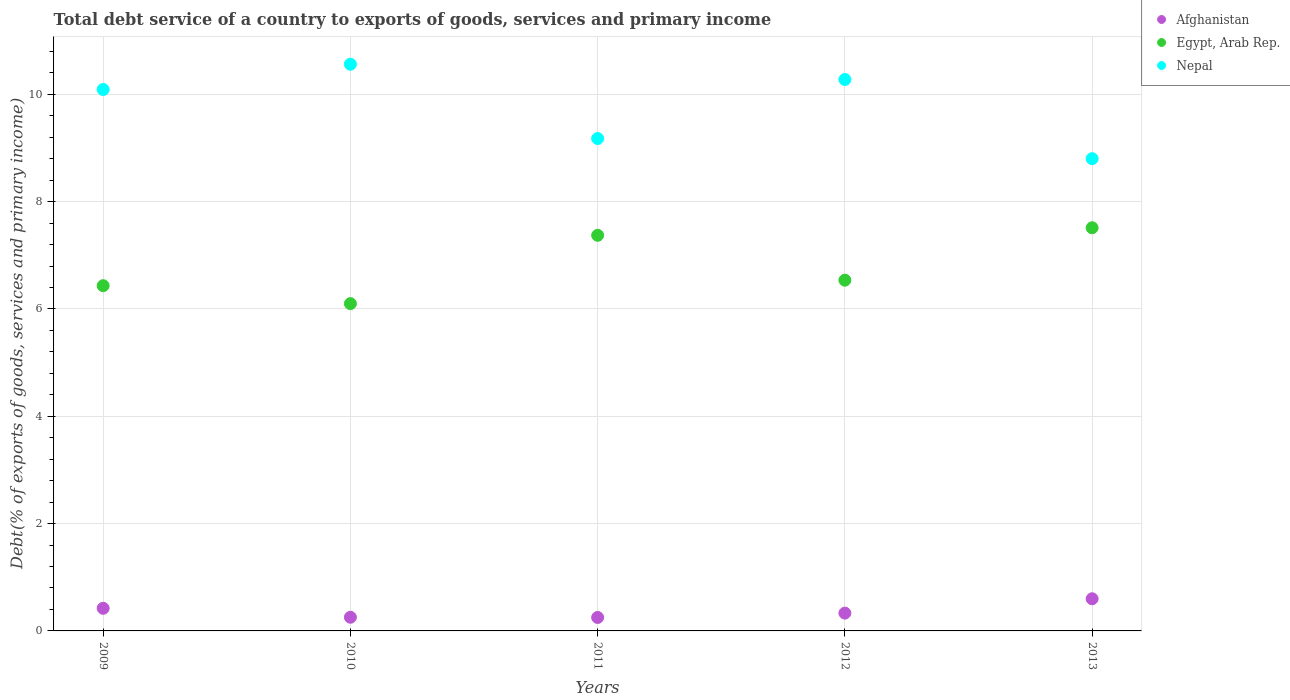How many different coloured dotlines are there?
Your response must be concise. 3. What is the total debt service in Afghanistan in 2009?
Give a very brief answer. 0.42. Across all years, what is the maximum total debt service in Afghanistan?
Your answer should be very brief. 0.6. Across all years, what is the minimum total debt service in Nepal?
Keep it short and to the point. 8.8. In which year was the total debt service in Egypt, Arab Rep. minimum?
Make the answer very short. 2010. What is the total total debt service in Afghanistan in the graph?
Offer a terse response. 1.86. What is the difference between the total debt service in Afghanistan in 2009 and that in 2011?
Offer a terse response. 0.17. What is the difference between the total debt service in Afghanistan in 2011 and the total debt service in Egypt, Arab Rep. in 2009?
Provide a succinct answer. -6.18. What is the average total debt service in Afghanistan per year?
Offer a very short reply. 0.37. In the year 2010, what is the difference between the total debt service in Egypt, Arab Rep. and total debt service in Nepal?
Your response must be concise. -4.46. What is the ratio of the total debt service in Egypt, Arab Rep. in 2009 to that in 2010?
Provide a short and direct response. 1.05. What is the difference between the highest and the second highest total debt service in Afghanistan?
Your response must be concise. 0.18. What is the difference between the highest and the lowest total debt service in Afghanistan?
Offer a terse response. 0.35. In how many years, is the total debt service in Nepal greater than the average total debt service in Nepal taken over all years?
Make the answer very short. 3. Is it the case that in every year, the sum of the total debt service in Afghanistan and total debt service in Egypt, Arab Rep.  is greater than the total debt service in Nepal?
Your answer should be compact. No. Does the total debt service in Afghanistan monotonically increase over the years?
Provide a succinct answer. No. How many dotlines are there?
Your answer should be compact. 3. Does the graph contain any zero values?
Ensure brevity in your answer.  No. Does the graph contain grids?
Ensure brevity in your answer.  Yes. Where does the legend appear in the graph?
Your response must be concise. Top right. How many legend labels are there?
Offer a terse response. 3. How are the legend labels stacked?
Your response must be concise. Vertical. What is the title of the graph?
Provide a short and direct response. Total debt service of a country to exports of goods, services and primary income. What is the label or title of the X-axis?
Provide a succinct answer. Years. What is the label or title of the Y-axis?
Provide a succinct answer. Debt(% of exports of goods, services and primary income). What is the Debt(% of exports of goods, services and primary income) in Afghanistan in 2009?
Keep it short and to the point. 0.42. What is the Debt(% of exports of goods, services and primary income) of Egypt, Arab Rep. in 2009?
Offer a terse response. 6.43. What is the Debt(% of exports of goods, services and primary income) in Nepal in 2009?
Keep it short and to the point. 10.09. What is the Debt(% of exports of goods, services and primary income) of Afghanistan in 2010?
Provide a succinct answer. 0.25. What is the Debt(% of exports of goods, services and primary income) in Egypt, Arab Rep. in 2010?
Your answer should be very brief. 6.1. What is the Debt(% of exports of goods, services and primary income) in Nepal in 2010?
Provide a short and direct response. 10.56. What is the Debt(% of exports of goods, services and primary income) of Afghanistan in 2011?
Provide a short and direct response. 0.25. What is the Debt(% of exports of goods, services and primary income) in Egypt, Arab Rep. in 2011?
Ensure brevity in your answer.  7.37. What is the Debt(% of exports of goods, services and primary income) of Nepal in 2011?
Your answer should be compact. 9.18. What is the Debt(% of exports of goods, services and primary income) in Afghanistan in 2012?
Make the answer very short. 0.33. What is the Debt(% of exports of goods, services and primary income) of Egypt, Arab Rep. in 2012?
Ensure brevity in your answer.  6.54. What is the Debt(% of exports of goods, services and primary income) in Nepal in 2012?
Give a very brief answer. 10.28. What is the Debt(% of exports of goods, services and primary income) of Afghanistan in 2013?
Make the answer very short. 0.6. What is the Debt(% of exports of goods, services and primary income) of Egypt, Arab Rep. in 2013?
Offer a terse response. 7.51. What is the Debt(% of exports of goods, services and primary income) in Nepal in 2013?
Provide a succinct answer. 8.8. Across all years, what is the maximum Debt(% of exports of goods, services and primary income) of Afghanistan?
Your answer should be very brief. 0.6. Across all years, what is the maximum Debt(% of exports of goods, services and primary income) in Egypt, Arab Rep.?
Make the answer very short. 7.51. Across all years, what is the maximum Debt(% of exports of goods, services and primary income) in Nepal?
Your response must be concise. 10.56. Across all years, what is the minimum Debt(% of exports of goods, services and primary income) of Afghanistan?
Your answer should be very brief. 0.25. Across all years, what is the minimum Debt(% of exports of goods, services and primary income) in Egypt, Arab Rep.?
Offer a terse response. 6.1. Across all years, what is the minimum Debt(% of exports of goods, services and primary income) in Nepal?
Offer a very short reply. 8.8. What is the total Debt(% of exports of goods, services and primary income) of Afghanistan in the graph?
Ensure brevity in your answer.  1.86. What is the total Debt(% of exports of goods, services and primary income) in Egypt, Arab Rep. in the graph?
Provide a succinct answer. 33.96. What is the total Debt(% of exports of goods, services and primary income) of Nepal in the graph?
Your response must be concise. 48.91. What is the difference between the Debt(% of exports of goods, services and primary income) in Afghanistan in 2009 and that in 2010?
Provide a succinct answer. 0.17. What is the difference between the Debt(% of exports of goods, services and primary income) in Egypt, Arab Rep. in 2009 and that in 2010?
Ensure brevity in your answer.  0.33. What is the difference between the Debt(% of exports of goods, services and primary income) of Nepal in 2009 and that in 2010?
Your answer should be compact. -0.47. What is the difference between the Debt(% of exports of goods, services and primary income) of Afghanistan in 2009 and that in 2011?
Offer a very short reply. 0.17. What is the difference between the Debt(% of exports of goods, services and primary income) of Egypt, Arab Rep. in 2009 and that in 2011?
Ensure brevity in your answer.  -0.94. What is the difference between the Debt(% of exports of goods, services and primary income) of Nepal in 2009 and that in 2011?
Your answer should be very brief. 0.91. What is the difference between the Debt(% of exports of goods, services and primary income) in Afghanistan in 2009 and that in 2012?
Provide a succinct answer. 0.09. What is the difference between the Debt(% of exports of goods, services and primary income) of Egypt, Arab Rep. in 2009 and that in 2012?
Offer a very short reply. -0.1. What is the difference between the Debt(% of exports of goods, services and primary income) in Nepal in 2009 and that in 2012?
Ensure brevity in your answer.  -0.19. What is the difference between the Debt(% of exports of goods, services and primary income) of Afghanistan in 2009 and that in 2013?
Your answer should be very brief. -0.18. What is the difference between the Debt(% of exports of goods, services and primary income) in Egypt, Arab Rep. in 2009 and that in 2013?
Provide a short and direct response. -1.08. What is the difference between the Debt(% of exports of goods, services and primary income) in Nepal in 2009 and that in 2013?
Provide a short and direct response. 1.29. What is the difference between the Debt(% of exports of goods, services and primary income) of Afghanistan in 2010 and that in 2011?
Make the answer very short. 0. What is the difference between the Debt(% of exports of goods, services and primary income) in Egypt, Arab Rep. in 2010 and that in 2011?
Your answer should be very brief. -1.27. What is the difference between the Debt(% of exports of goods, services and primary income) of Nepal in 2010 and that in 2011?
Keep it short and to the point. 1.38. What is the difference between the Debt(% of exports of goods, services and primary income) in Afghanistan in 2010 and that in 2012?
Give a very brief answer. -0.08. What is the difference between the Debt(% of exports of goods, services and primary income) of Egypt, Arab Rep. in 2010 and that in 2012?
Your response must be concise. -0.44. What is the difference between the Debt(% of exports of goods, services and primary income) of Nepal in 2010 and that in 2012?
Your answer should be very brief. 0.28. What is the difference between the Debt(% of exports of goods, services and primary income) of Afghanistan in 2010 and that in 2013?
Offer a terse response. -0.34. What is the difference between the Debt(% of exports of goods, services and primary income) of Egypt, Arab Rep. in 2010 and that in 2013?
Keep it short and to the point. -1.41. What is the difference between the Debt(% of exports of goods, services and primary income) in Nepal in 2010 and that in 2013?
Your answer should be very brief. 1.76. What is the difference between the Debt(% of exports of goods, services and primary income) of Afghanistan in 2011 and that in 2012?
Offer a very short reply. -0.08. What is the difference between the Debt(% of exports of goods, services and primary income) of Egypt, Arab Rep. in 2011 and that in 2012?
Make the answer very short. 0.84. What is the difference between the Debt(% of exports of goods, services and primary income) of Nepal in 2011 and that in 2012?
Your answer should be compact. -1.1. What is the difference between the Debt(% of exports of goods, services and primary income) in Afghanistan in 2011 and that in 2013?
Your response must be concise. -0.35. What is the difference between the Debt(% of exports of goods, services and primary income) of Egypt, Arab Rep. in 2011 and that in 2013?
Provide a succinct answer. -0.14. What is the difference between the Debt(% of exports of goods, services and primary income) in Nepal in 2011 and that in 2013?
Provide a succinct answer. 0.38. What is the difference between the Debt(% of exports of goods, services and primary income) in Afghanistan in 2012 and that in 2013?
Provide a succinct answer. -0.27. What is the difference between the Debt(% of exports of goods, services and primary income) in Egypt, Arab Rep. in 2012 and that in 2013?
Make the answer very short. -0.98. What is the difference between the Debt(% of exports of goods, services and primary income) in Nepal in 2012 and that in 2013?
Keep it short and to the point. 1.48. What is the difference between the Debt(% of exports of goods, services and primary income) in Afghanistan in 2009 and the Debt(% of exports of goods, services and primary income) in Egypt, Arab Rep. in 2010?
Provide a succinct answer. -5.68. What is the difference between the Debt(% of exports of goods, services and primary income) of Afghanistan in 2009 and the Debt(% of exports of goods, services and primary income) of Nepal in 2010?
Provide a short and direct response. -10.14. What is the difference between the Debt(% of exports of goods, services and primary income) of Egypt, Arab Rep. in 2009 and the Debt(% of exports of goods, services and primary income) of Nepal in 2010?
Keep it short and to the point. -4.13. What is the difference between the Debt(% of exports of goods, services and primary income) in Afghanistan in 2009 and the Debt(% of exports of goods, services and primary income) in Egypt, Arab Rep. in 2011?
Offer a terse response. -6.95. What is the difference between the Debt(% of exports of goods, services and primary income) of Afghanistan in 2009 and the Debt(% of exports of goods, services and primary income) of Nepal in 2011?
Provide a short and direct response. -8.75. What is the difference between the Debt(% of exports of goods, services and primary income) of Egypt, Arab Rep. in 2009 and the Debt(% of exports of goods, services and primary income) of Nepal in 2011?
Your answer should be very brief. -2.74. What is the difference between the Debt(% of exports of goods, services and primary income) of Afghanistan in 2009 and the Debt(% of exports of goods, services and primary income) of Egypt, Arab Rep. in 2012?
Make the answer very short. -6.11. What is the difference between the Debt(% of exports of goods, services and primary income) in Afghanistan in 2009 and the Debt(% of exports of goods, services and primary income) in Nepal in 2012?
Ensure brevity in your answer.  -9.85. What is the difference between the Debt(% of exports of goods, services and primary income) of Egypt, Arab Rep. in 2009 and the Debt(% of exports of goods, services and primary income) of Nepal in 2012?
Offer a terse response. -3.84. What is the difference between the Debt(% of exports of goods, services and primary income) in Afghanistan in 2009 and the Debt(% of exports of goods, services and primary income) in Egypt, Arab Rep. in 2013?
Provide a succinct answer. -7.09. What is the difference between the Debt(% of exports of goods, services and primary income) of Afghanistan in 2009 and the Debt(% of exports of goods, services and primary income) of Nepal in 2013?
Your response must be concise. -8.38. What is the difference between the Debt(% of exports of goods, services and primary income) of Egypt, Arab Rep. in 2009 and the Debt(% of exports of goods, services and primary income) of Nepal in 2013?
Give a very brief answer. -2.37. What is the difference between the Debt(% of exports of goods, services and primary income) of Afghanistan in 2010 and the Debt(% of exports of goods, services and primary income) of Egypt, Arab Rep. in 2011?
Offer a terse response. -7.12. What is the difference between the Debt(% of exports of goods, services and primary income) of Afghanistan in 2010 and the Debt(% of exports of goods, services and primary income) of Nepal in 2011?
Your answer should be very brief. -8.92. What is the difference between the Debt(% of exports of goods, services and primary income) in Egypt, Arab Rep. in 2010 and the Debt(% of exports of goods, services and primary income) in Nepal in 2011?
Your answer should be compact. -3.08. What is the difference between the Debt(% of exports of goods, services and primary income) of Afghanistan in 2010 and the Debt(% of exports of goods, services and primary income) of Egypt, Arab Rep. in 2012?
Ensure brevity in your answer.  -6.28. What is the difference between the Debt(% of exports of goods, services and primary income) of Afghanistan in 2010 and the Debt(% of exports of goods, services and primary income) of Nepal in 2012?
Offer a terse response. -10.02. What is the difference between the Debt(% of exports of goods, services and primary income) in Egypt, Arab Rep. in 2010 and the Debt(% of exports of goods, services and primary income) in Nepal in 2012?
Make the answer very short. -4.18. What is the difference between the Debt(% of exports of goods, services and primary income) of Afghanistan in 2010 and the Debt(% of exports of goods, services and primary income) of Egypt, Arab Rep. in 2013?
Ensure brevity in your answer.  -7.26. What is the difference between the Debt(% of exports of goods, services and primary income) of Afghanistan in 2010 and the Debt(% of exports of goods, services and primary income) of Nepal in 2013?
Offer a very short reply. -8.55. What is the difference between the Debt(% of exports of goods, services and primary income) in Egypt, Arab Rep. in 2010 and the Debt(% of exports of goods, services and primary income) in Nepal in 2013?
Provide a succinct answer. -2.7. What is the difference between the Debt(% of exports of goods, services and primary income) in Afghanistan in 2011 and the Debt(% of exports of goods, services and primary income) in Egypt, Arab Rep. in 2012?
Give a very brief answer. -6.29. What is the difference between the Debt(% of exports of goods, services and primary income) of Afghanistan in 2011 and the Debt(% of exports of goods, services and primary income) of Nepal in 2012?
Keep it short and to the point. -10.03. What is the difference between the Debt(% of exports of goods, services and primary income) of Egypt, Arab Rep. in 2011 and the Debt(% of exports of goods, services and primary income) of Nepal in 2012?
Keep it short and to the point. -2.9. What is the difference between the Debt(% of exports of goods, services and primary income) of Afghanistan in 2011 and the Debt(% of exports of goods, services and primary income) of Egypt, Arab Rep. in 2013?
Your answer should be compact. -7.26. What is the difference between the Debt(% of exports of goods, services and primary income) in Afghanistan in 2011 and the Debt(% of exports of goods, services and primary income) in Nepal in 2013?
Your response must be concise. -8.55. What is the difference between the Debt(% of exports of goods, services and primary income) in Egypt, Arab Rep. in 2011 and the Debt(% of exports of goods, services and primary income) in Nepal in 2013?
Ensure brevity in your answer.  -1.43. What is the difference between the Debt(% of exports of goods, services and primary income) in Afghanistan in 2012 and the Debt(% of exports of goods, services and primary income) in Egypt, Arab Rep. in 2013?
Give a very brief answer. -7.18. What is the difference between the Debt(% of exports of goods, services and primary income) in Afghanistan in 2012 and the Debt(% of exports of goods, services and primary income) in Nepal in 2013?
Provide a short and direct response. -8.47. What is the difference between the Debt(% of exports of goods, services and primary income) in Egypt, Arab Rep. in 2012 and the Debt(% of exports of goods, services and primary income) in Nepal in 2013?
Provide a succinct answer. -2.26. What is the average Debt(% of exports of goods, services and primary income) in Afghanistan per year?
Your answer should be very brief. 0.37. What is the average Debt(% of exports of goods, services and primary income) of Egypt, Arab Rep. per year?
Ensure brevity in your answer.  6.79. What is the average Debt(% of exports of goods, services and primary income) in Nepal per year?
Provide a short and direct response. 9.78. In the year 2009, what is the difference between the Debt(% of exports of goods, services and primary income) in Afghanistan and Debt(% of exports of goods, services and primary income) in Egypt, Arab Rep.?
Offer a very short reply. -6.01. In the year 2009, what is the difference between the Debt(% of exports of goods, services and primary income) in Afghanistan and Debt(% of exports of goods, services and primary income) in Nepal?
Provide a succinct answer. -9.67. In the year 2009, what is the difference between the Debt(% of exports of goods, services and primary income) of Egypt, Arab Rep. and Debt(% of exports of goods, services and primary income) of Nepal?
Give a very brief answer. -3.66. In the year 2010, what is the difference between the Debt(% of exports of goods, services and primary income) in Afghanistan and Debt(% of exports of goods, services and primary income) in Egypt, Arab Rep.?
Provide a short and direct response. -5.84. In the year 2010, what is the difference between the Debt(% of exports of goods, services and primary income) of Afghanistan and Debt(% of exports of goods, services and primary income) of Nepal?
Offer a very short reply. -10.31. In the year 2010, what is the difference between the Debt(% of exports of goods, services and primary income) in Egypt, Arab Rep. and Debt(% of exports of goods, services and primary income) in Nepal?
Your answer should be very brief. -4.46. In the year 2011, what is the difference between the Debt(% of exports of goods, services and primary income) of Afghanistan and Debt(% of exports of goods, services and primary income) of Egypt, Arab Rep.?
Your answer should be very brief. -7.12. In the year 2011, what is the difference between the Debt(% of exports of goods, services and primary income) of Afghanistan and Debt(% of exports of goods, services and primary income) of Nepal?
Your answer should be very brief. -8.93. In the year 2011, what is the difference between the Debt(% of exports of goods, services and primary income) in Egypt, Arab Rep. and Debt(% of exports of goods, services and primary income) in Nepal?
Your answer should be compact. -1.8. In the year 2012, what is the difference between the Debt(% of exports of goods, services and primary income) in Afghanistan and Debt(% of exports of goods, services and primary income) in Egypt, Arab Rep.?
Offer a very short reply. -6.2. In the year 2012, what is the difference between the Debt(% of exports of goods, services and primary income) in Afghanistan and Debt(% of exports of goods, services and primary income) in Nepal?
Offer a very short reply. -9.94. In the year 2012, what is the difference between the Debt(% of exports of goods, services and primary income) in Egypt, Arab Rep. and Debt(% of exports of goods, services and primary income) in Nepal?
Offer a terse response. -3.74. In the year 2013, what is the difference between the Debt(% of exports of goods, services and primary income) in Afghanistan and Debt(% of exports of goods, services and primary income) in Egypt, Arab Rep.?
Make the answer very short. -6.91. In the year 2013, what is the difference between the Debt(% of exports of goods, services and primary income) in Afghanistan and Debt(% of exports of goods, services and primary income) in Nepal?
Keep it short and to the point. -8.2. In the year 2013, what is the difference between the Debt(% of exports of goods, services and primary income) in Egypt, Arab Rep. and Debt(% of exports of goods, services and primary income) in Nepal?
Your answer should be very brief. -1.29. What is the ratio of the Debt(% of exports of goods, services and primary income) in Afghanistan in 2009 to that in 2010?
Give a very brief answer. 1.65. What is the ratio of the Debt(% of exports of goods, services and primary income) in Egypt, Arab Rep. in 2009 to that in 2010?
Your response must be concise. 1.05. What is the ratio of the Debt(% of exports of goods, services and primary income) of Nepal in 2009 to that in 2010?
Your response must be concise. 0.96. What is the ratio of the Debt(% of exports of goods, services and primary income) in Afghanistan in 2009 to that in 2011?
Give a very brief answer. 1.68. What is the ratio of the Debt(% of exports of goods, services and primary income) of Egypt, Arab Rep. in 2009 to that in 2011?
Offer a terse response. 0.87. What is the ratio of the Debt(% of exports of goods, services and primary income) in Nepal in 2009 to that in 2011?
Your answer should be very brief. 1.1. What is the ratio of the Debt(% of exports of goods, services and primary income) of Afghanistan in 2009 to that in 2012?
Ensure brevity in your answer.  1.27. What is the ratio of the Debt(% of exports of goods, services and primary income) of Egypt, Arab Rep. in 2009 to that in 2012?
Offer a very short reply. 0.98. What is the ratio of the Debt(% of exports of goods, services and primary income) in Nepal in 2009 to that in 2012?
Provide a short and direct response. 0.98. What is the ratio of the Debt(% of exports of goods, services and primary income) in Afghanistan in 2009 to that in 2013?
Keep it short and to the point. 0.7. What is the ratio of the Debt(% of exports of goods, services and primary income) in Egypt, Arab Rep. in 2009 to that in 2013?
Provide a succinct answer. 0.86. What is the ratio of the Debt(% of exports of goods, services and primary income) of Nepal in 2009 to that in 2013?
Offer a terse response. 1.15. What is the ratio of the Debt(% of exports of goods, services and primary income) of Afghanistan in 2010 to that in 2011?
Ensure brevity in your answer.  1.02. What is the ratio of the Debt(% of exports of goods, services and primary income) of Egypt, Arab Rep. in 2010 to that in 2011?
Your answer should be very brief. 0.83. What is the ratio of the Debt(% of exports of goods, services and primary income) of Nepal in 2010 to that in 2011?
Ensure brevity in your answer.  1.15. What is the ratio of the Debt(% of exports of goods, services and primary income) of Afghanistan in 2010 to that in 2012?
Provide a succinct answer. 0.77. What is the ratio of the Debt(% of exports of goods, services and primary income) of Egypt, Arab Rep. in 2010 to that in 2012?
Ensure brevity in your answer.  0.93. What is the ratio of the Debt(% of exports of goods, services and primary income) in Nepal in 2010 to that in 2012?
Your answer should be compact. 1.03. What is the ratio of the Debt(% of exports of goods, services and primary income) in Afghanistan in 2010 to that in 2013?
Offer a very short reply. 0.43. What is the ratio of the Debt(% of exports of goods, services and primary income) in Egypt, Arab Rep. in 2010 to that in 2013?
Your response must be concise. 0.81. What is the ratio of the Debt(% of exports of goods, services and primary income) in Afghanistan in 2011 to that in 2012?
Provide a succinct answer. 0.76. What is the ratio of the Debt(% of exports of goods, services and primary income) in Egypt, Arab Rep. in 2011 to that in 2012?
Your answer should be very brief. 1.13. What is the ratio of the Debt(% of exports of goods, services and primary income) in Nepal in 2011 to that in 2012?
Provide a short and direct response. 0.89. What is the ratio of the Debt(% of exports of goods, services and primary income) in Afghanistan in 2011 to that in 2013?
Ensure brevity in your answer.  0.42. What is the ratio of the Debt(% of exports of goods, services and primary income) in Egypt, Arab Rep. in 2011 to that in 2013?
Provide a short and direct response. 0.98. What is the ratio of the Debt(% of exports of goods, services and primary income) in Nepal in 2011 to that in 2013?
Offer a terse response. 1.04. What is the ratio of the Debt(% of exports of goods, services and primary income) in Afghanistan in 2012 to that in 2013?
Give a very brief answer. 0.55. What is the ratio of the Debt(% of exports of goods, services and primary income) of Egypt, Arab Rep. in 2012 to that in 2013?
Keep it short and to the point. 0.87. What is the ratio of the Debt(% of exports of goods, services and primary income) in Nepal in 2012 to that in 2013?
Ensure brevity in your answer.  1.17. What is the difference between the highest and the second highest Debt(% of exports of goods, services and primary income) of Afghanistan?
Keep it short and to the point. 0.18. What is the difference between the highest and the second highest Debt(% of exports of goods, services and primary income) of Egypt, Arab Rep.?
Make the answer very short. 0.14. What is the difference between the highest and the second highest Debt(% of exports of goods, services and primary income) of Nepal?
Provide a short and direct response. 0.28. What is the difference between the highest and the lowest Debt(% of exports of goods, services and primary income) in Afghanistan?
Provide a short and direct response. 0.35. What is the difference between the highest and the lowest Debt(% of exports of goods, services and primary income) in Egypt, Arab Rep.?
Ensure brevity in your answer.  1.41. What is the difference between the highest and the lowest Debt(% of exports of goods, services and primary income) of Nepal?
Keep it short and to the point. 1.76. 